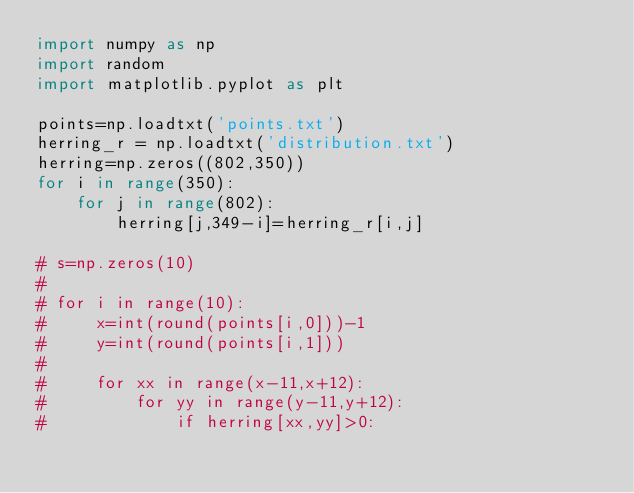<code> <loc_0><loc_0><loc_500><loc_500><_Python_>import numpy as np
import random
import matplotlib.pyplot as plt

points=np.loadtxt('points.txt')
herring_r = np.loadtxt('distribution.txt')
herring=np.zeros((802,350))
for i in range(350):
    for j in range(802):
        herring[j,349-i]=herring_r[i,j]

# s=np.zeros(10)
#
# for i in range(10):
#     x=int(round(points[i,0]))-1
#     y=int(round(points[i,1]))
#
#     for xx in range(x-11,x+12):
#         for yy in range(y-11,y+12):
#             if herring[xx,yy]>0:</code> 